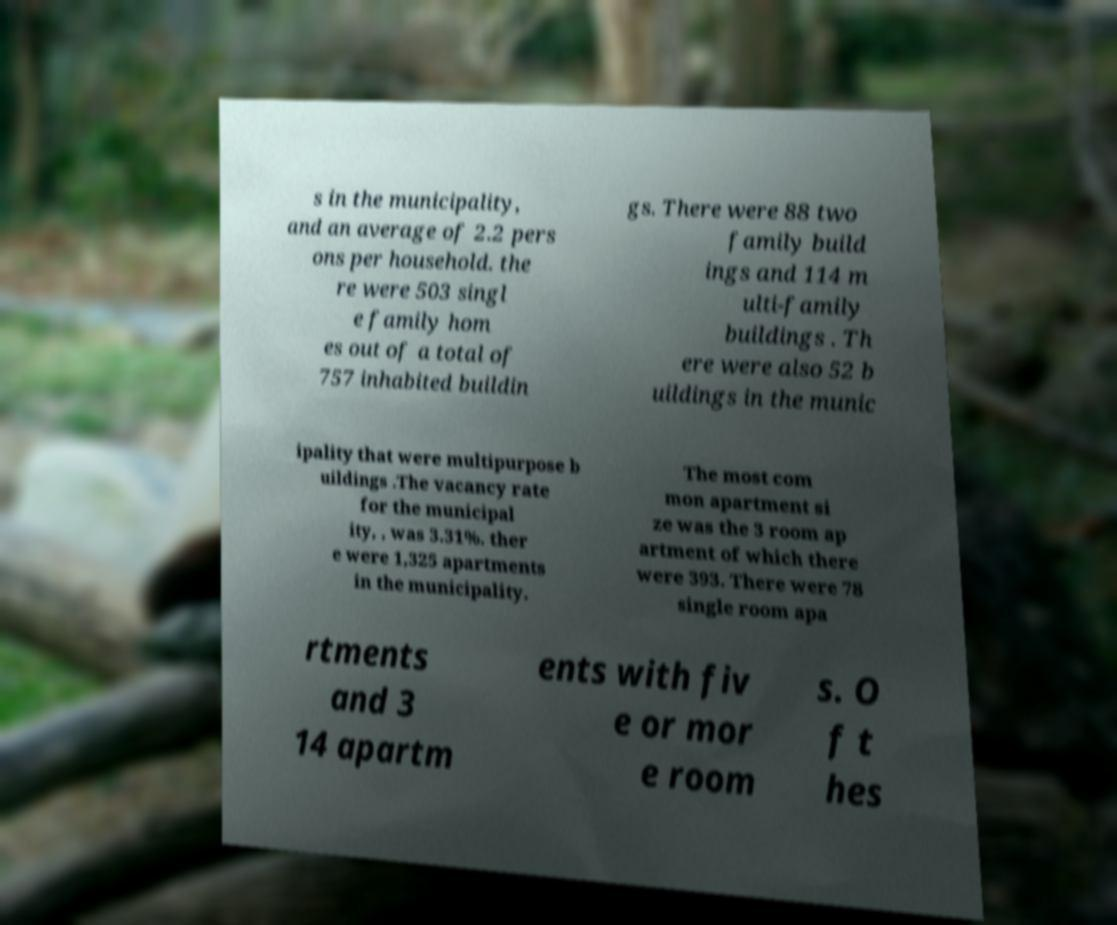For documentation purposes, I need the text within this image transcribed. Could you provide that? s in the municipality, and an average of 2.2 pers ons per household. the re were 503 singl e family hom es out of a total of 757 inhabited buildin gs. There were 88 two family build ings and 114 m ulti-family buildings . Th ere were also 52 b uildings in the munic ipality that were multipurpose b uildings .The vacancy rate for the municipal ity, , was 3.31%. ther e were 1,325 apartments in the municipality. The most com mon apartment si ze was the 3 room ap artment of which there were 393. There were 78 single room apa rtments and 3 14 apartm ents with fiv e or mor e room s. O f t hes 